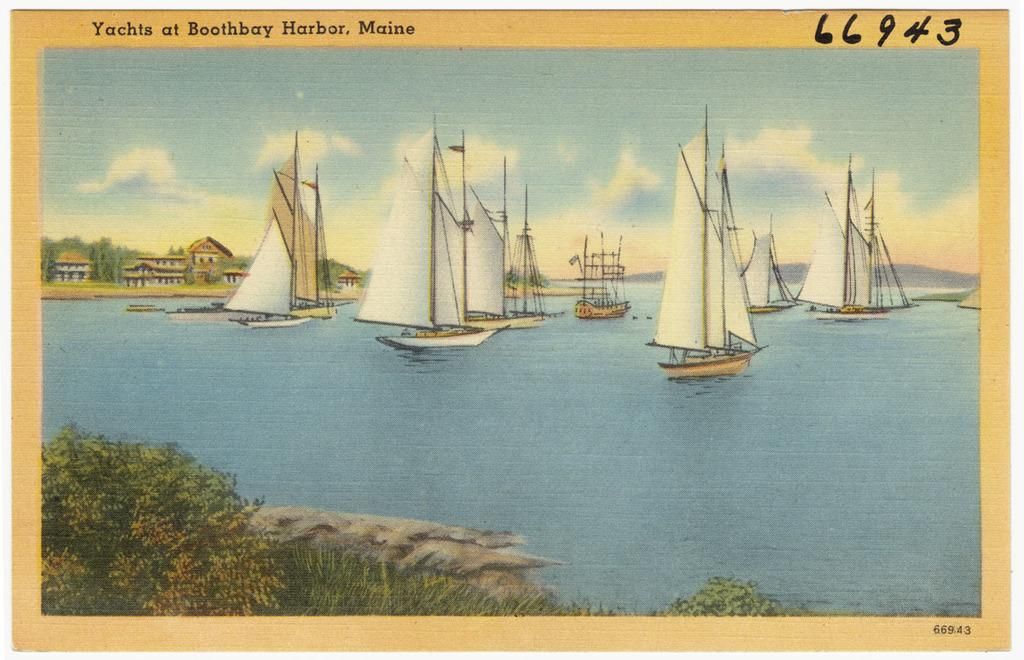<image>
Describe the image concisely. The title of the art is Yachts at Boothbay Harbor, Maine. 